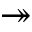Convert formula to latex. <formula><loc_0><loc_0><loc_500><loc_500>\twoheadrightarrow</formula> 